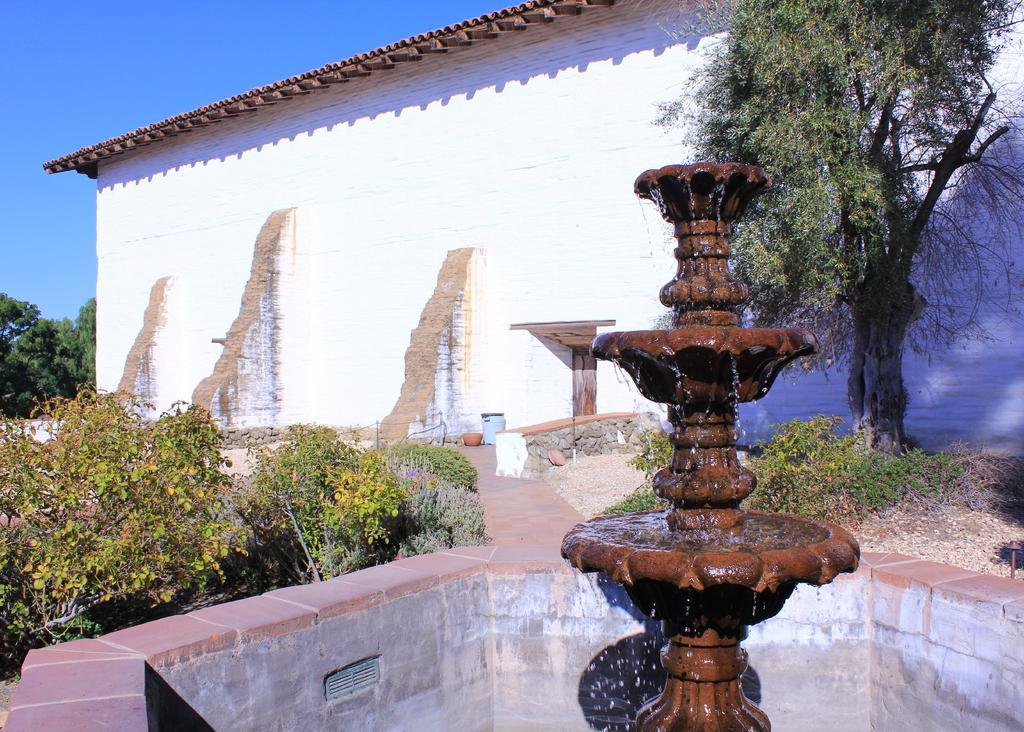Can you describe this image briefly? In this picture we can see a fountain with water and beside the fountain we can see planets, path, some objects and in the background we can see a building, trees, sky. 